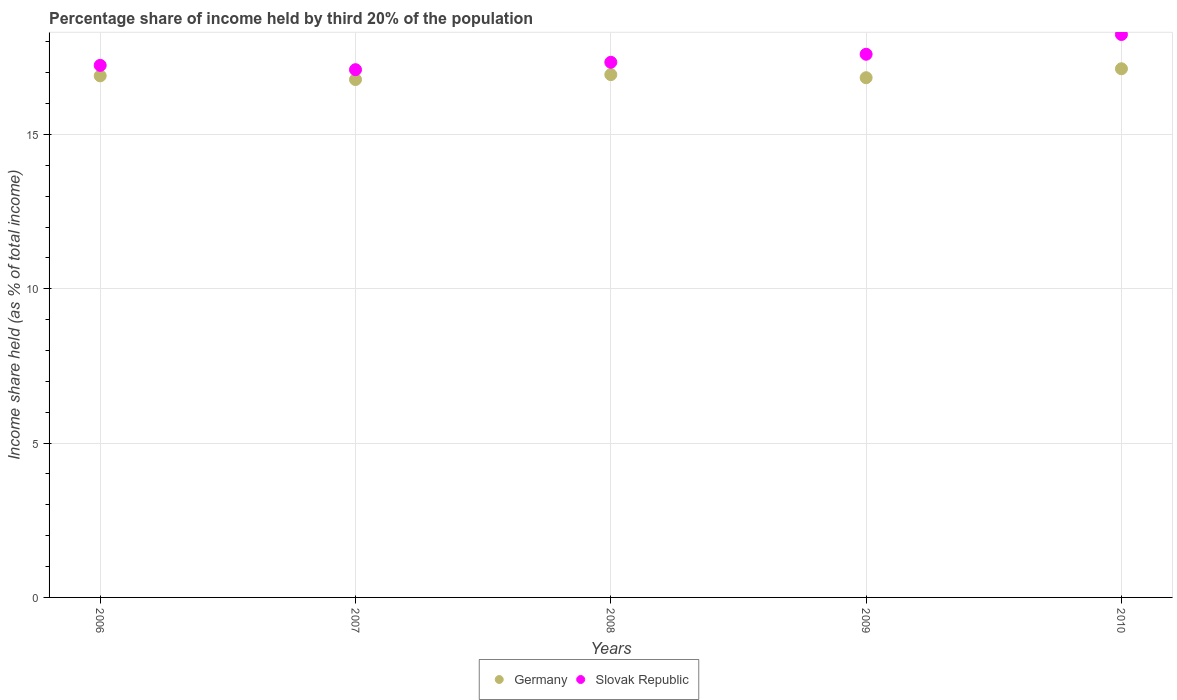Is the number of dotlines equal to the number of legend labels?
Ensure brevity in your answer.  Yes. What is the share of income held by third 20% of the population in Germany in 2008?
Offer a terse response. 16.94. Across all years, what is the maximum share of income held by third 20% of the population in Germany?
Make the answer very short. 17.13. Across all years, what is the minimum share of income held by third 20% of the population in Germany?
Keep it short and to the point. 16.78. What is the total share of income held by third 20% of the population in Germany in the graph?
Provide a succinct answer. 84.59. What is the difference between the share of income held by third 20% of the population in Slovak Republic in 2006 and the share of income held by third 20% of the population in Germany in 2009?
Give a very brief answer. 0.4. What is the average share of income held by third 20% of the population in Germany per year?
Your answer should be compact. 16.92. In the year 2007, what is the difference between the share of income held by third 20% of the population in Slovak Republic and share of income held by third 20% of the population in Germany?
Your answer should be compact. 0.32. What is the ratio of the share of income held by third 20% of the population in Slovak Republic in 2007 to that in 2009?
Your answer should be very brief. 0.97. Is the difference between the share of income held by third 20% of the population in Slovak Republic in 2007 and 2009 greater than the difference between the share of income held by third 20% of the population in Germany in 2007 and 2009?
Make the answer very short. No. What is the difference between the highest and the second highest share of income held by third 20% of the population in Germany?
Your answer should be compact. 0.19. What is the difference between the highest and the lowest share of income held by third 20% of the population in Slovak Republic?
Provide a short and direct response. 1.14. Is the sum of the share of income held by third 20% of the population in Slovak Republic in 2006 and 2009 greater than the maximum share of income held by third 20% of the population in Germany across all years?
Keep it short and to the point. Yes. Does the share of income held by third 20% of the population in Slovak Republic monotonically increase over the years?
Give a very brief answer. No. Is the share of income held by third 20% of the population in Germany strictly less than the share of income held by third 20% of the population in Slovak Republic over the years?
Provide a short and direct response. Yes. How many dotlines are there?
Your answer should be very brief. 2. Are the values on the major ticks of Y-axis written in scientific E-notation?
Provide a succinct answer. No. Does the graph contain any zero values?
Keep it short and to the point. No. Where does the legend appear in the graph?
Your response must be concise. Bottom center. How are the legend labels stacked?
Your answer should be very brief. Horizontal. What is the title of the graph?
Offer a terse response. Percentage share of income held by third 20% of the population. Does "Finland" appear as one of the legend labels in the graph?
Offer a very short reply. No. What is the label or title of the X-axis?
Keep it short and to the point. Years. What is the label or title of the Y-axis?
Your answer should be compact. Income share held (as % of total income). What is the Income share held (as % of total income) in Slovak Republic in 2006?
Your answer should be compact. 17.24. What is the Income share held (as % of total income) of Germany in 2007?
Your response must be concise. 16.78. What is the Income share held (as % of total income) in Germany in 2008?
Ensure brevity in your answer.  16.94. What is the Income share held (as % of total income) in Slovak Republic in 2008?
Your answer should be very brief. 17.34. What is the Income share held (as % of total income) of Germany in 2009?
Provide a short and direct response. 16.84. What is the Income share held (as % of total income) in Germany in 2010?
Offer a terse response. 17.13. What is the Income share held (as % of total income) in Slovak Republic in 2010?
Provide a short and direct response. 18.24. Across all years, what is the maximum Income share held (as % of total income) of Germany?
Provide a short and direct response. 17.13. Across all years, what is the maximum Income share held (as % of total income) in Slovak Republic?
Your answer should be compact. 18.24. Across all years, what is the minimum Income share held (as % of total income) of Germany?
Your response must be concise. 16.78. What is the total Income share held (as % of total income) of Germany in the graph?
Your answer should be compact. 84.59. What is the total Income share held (as % of total income) of Slovak Republic in the graph?
Provide a short and direct response. 87.52. What is the difference between the Income share held (as % of total income) in Germany in 2006 and that in 2007?
Offer a terse response. 0.12. What is the difference between the Income share held (as % of total income) in Slovak Republic in 2006 and that in 2007?
Provide a succinct answer. 0.14. What is the difference between the Income share held (as % of total income) of Germany in 2006 and that in 2008?
Ensure brevity in your answer.  -0.04. What is the difference between the Income share held (as % of total income) in Slovak Republic in 2006 and that in 2008?
Offer a very short reply. -0.1. What is the difference between the Income share held (as % of total income) of Germany in 2006 and that in 2009?
Offer a very short reply. 0.06. What is the difference between the Income share held (as % of total income) of Slovak Republic in 2006 and that in 2009?
Keep it short and to the point. -0.36. What is the difference between the Income share held (as % of total income) in Germany in 2006 and that in 2010?
Offer a very short reply. -0.23. What is the difference between the Income share held (as % of total income) in Slovak Republic in 2006 and that in 2010?
Provide a short and direct response. -1. What is the difference between the Income share held (as % of total income) of Germany in 2007 and that in 2008?
Provide a short and direct response. -0.16. What is the difference between the Income share held (as % of total income) in Slovak Republic in 2007 and that in 2008?
Ensure brevity in your answer.  -0.24. What is the difference between the Income share held (as % of total income) of Germany in 2007 and that in 2009?
Make the answer very short. -0.06. What is the difference between the Income share held (as % of total income) of Slovak Republic in 2007 and that in 2009?
Offer a terse response. -0.5. What is the difference between the Income share held (as % of total income) of Germany in 2007 and that in 2010?
Offer a terse response. -0.35. What is the difference between the Income share held (as % of total income) in Slovak Republic in 2007 and that in 2010?
Ensure brevity in your answer.  -1.14. What is the difference between the Income share held (as % of total income) in Slovak Republic in 2008 and that in 2009?
Provide a short and direct response. -0.26. What is the difference between the Income share held (as % of total income) of Germany in 2008 and that in 2010?
Your answer should be very brief. -0.19. What is the difference between the Income share held (as % of total income) in Slovak Republic in 2008 and that in 2010?
Your answer should be very brief. -0.9. What is the difference between the Income share held (as % of total income) in Germany in 2009 and that in 2010?
Your response must be concise. -0.29. What is the difference between the Income share held (as % of total income) of Slovak Republic in 2009 and that in 2010?
Your answer should be very brief. -0.64. What is the difference between the Income share held (as % of total income) of Germany in 2006 and the Income share held (as % of total income) of Slovak Republic in 2007?
Offer a very short reply. -0.2. What is the difference between the Income share held (as % of total income) in Germany in 2006 and the Income share held (as % of total income) in Slovak Republic in 2008?
Keep it short and to the point. -0.44. What is the difference between the Income share held (as % of total income) in Germany in 2006 and the Income share held (as % of total income) in Slovak Republic in 2010?
Provide a short and direct response. -1.34. What is the difference between the Income share held (as % of total income) in Germany in 2007 and the Income share held (as % of total income) in Slovak Republic in 2008?
Your answer should be compact. -0.56. What is the difference between the Income share held (as % of total income) in Germany in 2007 and the Income share held (as % of total income) in Slovak Republic in 2009?
Offer a very short reply. -0.82. What is the difference between the Income share held (as % of total income) in Germany in 2007 and the Income share held (as % of total income) in Slovak Republic in 2010?
Give a very brief answer. -1.46. What is the difference between the Income share held (as % of total income) in Germany in 2008 and the Income share held (as % of total income) in Slovak Republic in 2009?
Your response must be concise. -0.66. What is the difference between the Income share held (as % of total income) of Germany in 2009 and the Income share held (as % of total income) of Slovak Republic in 2010?
Your response must be concise. -1.4. What is the average Income share held (as % of total income) in Germany per year?
Keep it short and to the point. 16.92. What is the average Income share held (as % of total income) of Slovak Republic per year?
Provide a succinct answer. 17.5. In the year 2006, what is the difference between the Income share held (as % of total income) of Germany and Income share held (as % of total income) of Slovak Republic?
Offer a very short reply. -0.34. In the year 2007, what is the difference between the Income share held (as % of total income) of Germany and Income share held (as % of total income) of Slovak Republic?
Ensure brevity in your answer.  -0.32. In the year 2009, what is the difference between the Income share held (as % of total income) in Germany and Income share held (as % of total income) in Slovak Republic?
Your answer should be very brief. -0.76. In the year 2010, what is the difference between the Income share held (as % of total income) in Germany and Income share held (as % of total income) in Slovak Republic?
Ensure brevity in your answer.  -1.11. What is the ratio of the Income share held (as % of total income) in Germany in 2006 to that in 2007?
Provide a short and direct response. 1.01. What is the ratio of the Income share held (as % of total income) in Slovak Republic in 2006 to that in 2007?
Give a very brief answer. 1.01. What is the ratio of the Income share held (as % of total income) in Germany in 2006 to that in 2008?
Keep it short and to the point. 1. What is the ratio of the Income share held (as % of total income) in Slovak Republic in 2006 to that in 2009?
Your response must be concise. 0.98. What is the ratio of the Income share held (as % of total income) in Germany in 2006 to that in 2010?
Your answer should be compact. 0.99. What is the ratio of the Income share held (as % of total income) of Slovak Republic in 2006 to that in 2010?
Offer a terse response. 0.95. What is the ratio of the Income share held (as % of total income) of Germany in 2007 to that in 2008?
Make the answer very short. 0.99. What is the ratio of the Income share held (as % of total income) of Slovak Republic in 2007 to that in 2008?
Your answer should be compact. 0.99. What is the ratio of the Income share held (as % of total income) of Slovak Republic in 2007 to that in 2009?
Give a very brief answer. 0.97. What is the ratio of the Income share held (as % of total income) of Germany in 2007 to that in 2010?
Your answer should be very brief. 0.98. What is the ratio of the Income share held (as % of total income) of Germany in 2008 to that in 2009?
Your answer should be very brief. 1.01. What is the ratio of the Income share held (as % of total income) in Slovak Republic in 2008 to that in 2009?
Offer a very short reply. 0.99. What is the ratio of the Income share held (as % of total income) of Germany in 2008 to that in 2010?
Your answer should be very brief. 0.99. What is the ratio of the Income share held (as % of total income) of Slovak Republic in 2008 to that in 2010?
Your answer should be compact. 0.95. What is the ratio of the Income share held (as % of total income) in Germany in 2009 to that in 2010?
Make the answer very short. 0.98. What is the ratio of the Income share held (as % of total income) of Slovak Republic in 2009 to that in 2010?
Provide a short and direct response. 0.96. What is the difference between the highest and the second highest Income share held (as % of total income) of Germany?
Offer a terse response. 0.19. What is the difference between the highest and the second highest Income share held (as % of total income) of Slovak Republic?
Make the answer very short. 0.64. What is the difference between the highest and the lowest Income share held (as % of total income) in Slovak Republic?
Provide a short and direct response. 1.14. 